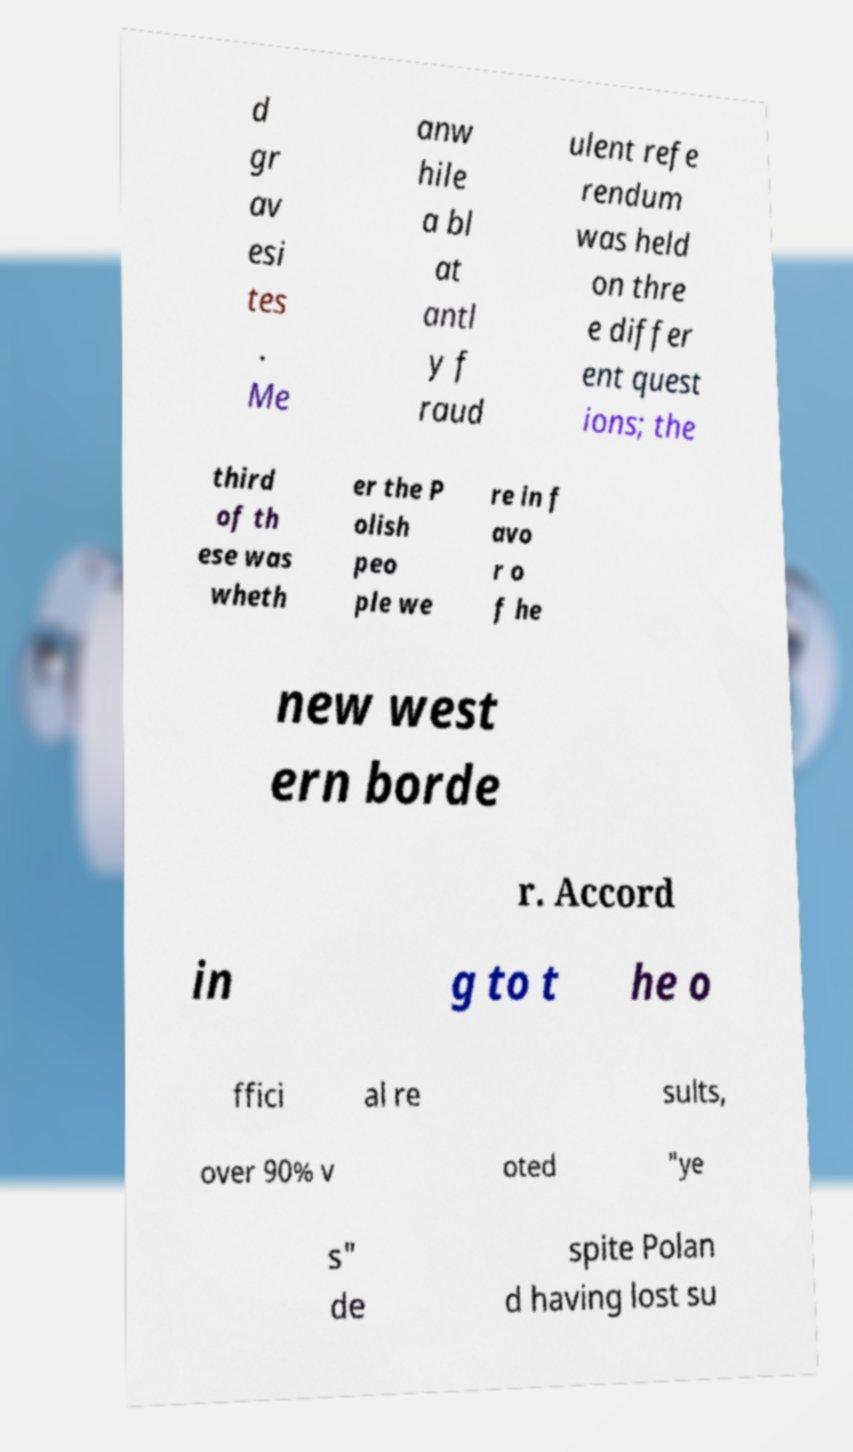Please identify and transcribe the text found in this image. d gr av esi tes . Me anw hile a bl at antl y f raud ulent refe rendum was held on thre e differ ent quest ions; the third of th ese was wheth er the P olish peo ple we re in f avo r o f he new west ern borde r. Accord in g to t he o ffici al re sults, over 90% v oted "ye s" de spite Polan d having lost su 